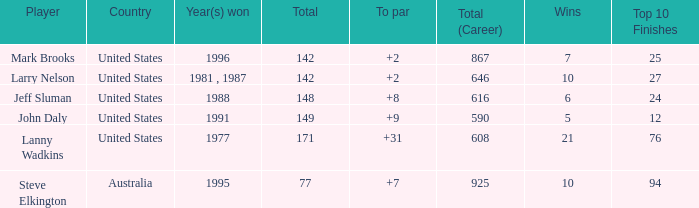Name the To par that has a Year(s) won of 1988 and a Total smaller than 148? None. 